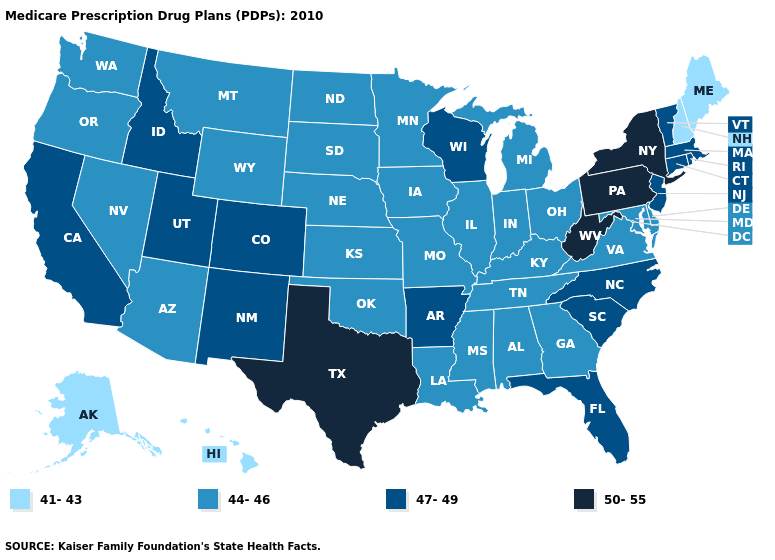Name the states that have a value in the range 44-46?
Short answer required. Alabama, Arizona, Delaware, Georgia, Iowa, Illinois, Indiana, Kansas, Kentucky, Louisiana, Maryland, Michigan, Minnesota, Missouri, Mississippi, Montana, North Dakota, Nebraska, Nevada, Ohio, Oklahoma, Oregon, South Dakota, Tennessee, Virginia, Washington, Wyoming. Does Wisconsin have a lower value than Texas?
Be succinct. Yes. What is the highest value in the USA?
Keep it brief. 50-55. Which states have the lowest value in the USA?
Quick response, please. Alaska, Hawaii, Maine, New Hampshire. Does Nevada have a lower value than Delaware?
Short answer required. No. Which states have the highest value in the USA?
Write a very short answer. New York, Pennsylvania, Texas, West Virginia. What is the value of Indiana?
Be succinct. 44-46. Does Washington have a higher value than Wisconsin?
Concise answer only. No. Does North Carolina have the lowest value in the USA?
Keep it brief. No. What is the highest value in the USA?
Keep it brief. 50-55. What is the highest value in the South ?
Give a very brief answer. 50-55. Among the states that border Georgia , which have the highest value?
Keep it brief. Florida, North Carolina, South Carolina. What is the value of Kentucky?
Quick response, please. 44-46. Does New York have the same value as Texas?
Short answer required. Yes. 